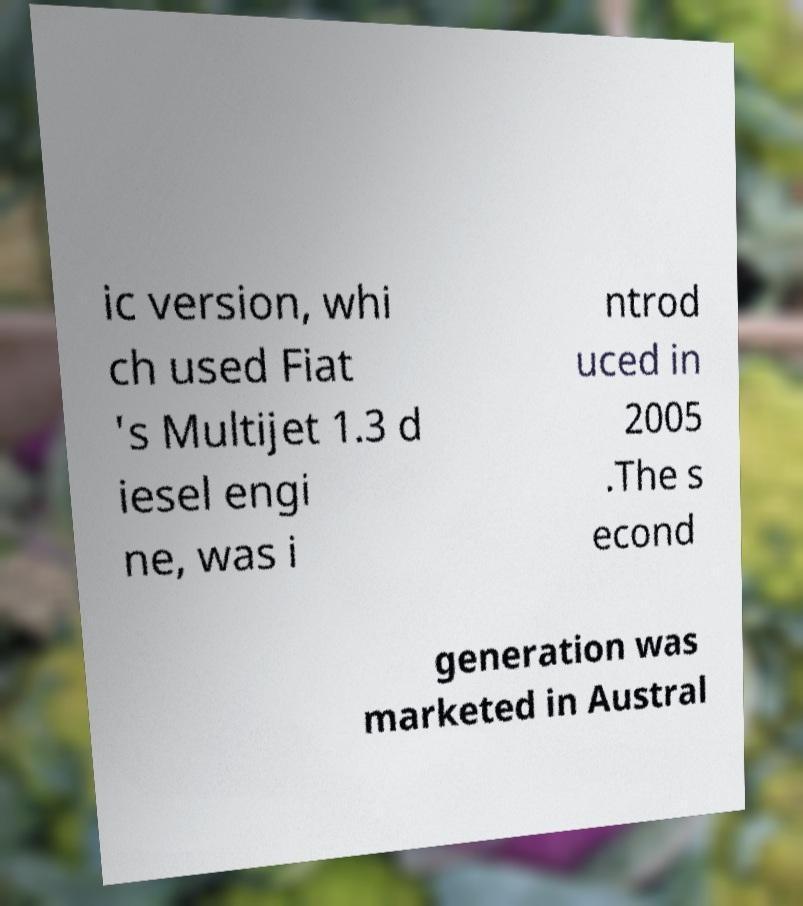Can you accurately transcribe the text from the provided image for me? ic version, whi ch used Fiat 's Multijet 1.3 d iesel engi ne, was i ntrod uced in 2005 .The s econd generation was marketed in Austral 